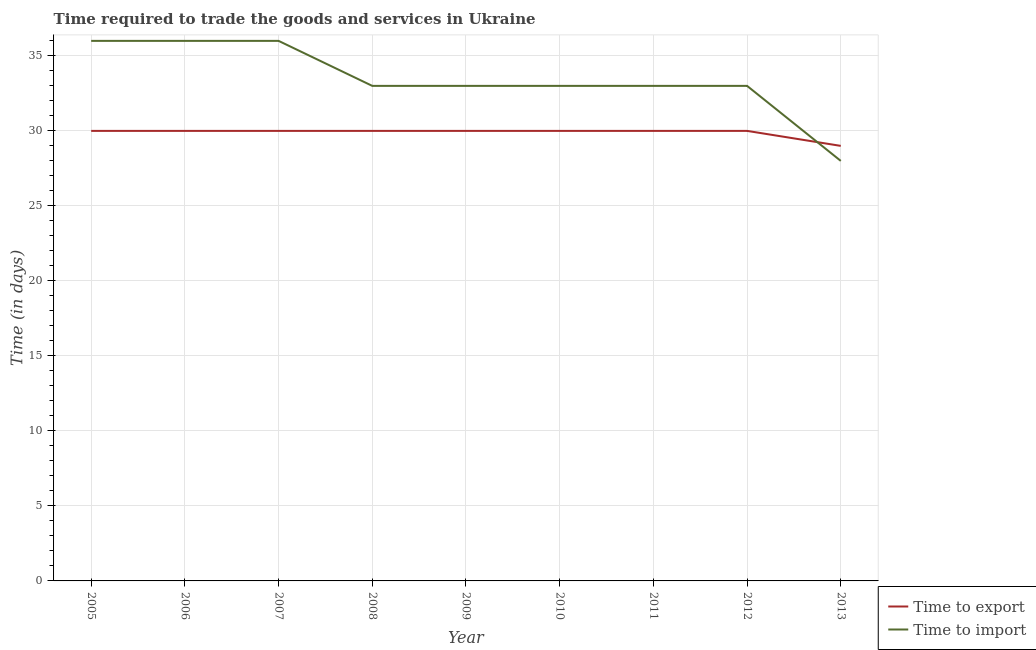Is the number of lines equal to the number of legend labels?
Your answer should be compact. Yes. What is the time to import in 2005?
Offer a very short reply. 36. Across all years, what is the maximum time to import?
Ensure brevity in your answer.  36. Across all years, what is the minimum time to import?
Provide a succinct answer. 28. In which year was the time to export minimum?
Ensure brevity in your answer.  2013. What is the total time to export in the graph?
Provide a succinct answer. 269. What is the difference between the time to import in 2005 and that in 2012?
Offer a terse response. 3. What is the difference between the time to export in 2010 and the time to import in 2009?
Your response must be concise. -3. What is the average time to import per year?
Your answer should be compact. 33.44. In the year 2008, what is the difference between the time to import and time to export?
Ensure brevity in your answer.  3. In how many years, is the time to export greater than 19 days?
Offer a terse response. 9. What is the ratio of the time to import in 2005 to that in 2013?
Your response must be concise. 1.29. Is the time to export in 2006 less than that in 2013?
Offer a terse response. No. What is the difference between the highest and the lowest time to export?
Your answer should be compact. 1. In how many years, is the time to import greater than the average time to import taken over all years?
Keep it short and to the point. 3. Is the sum of the time to import in 2010 and 2013 greater than the maximum time to export across all years?
Keep it short and to the point. Yes. Does the time to export monotonically increase over the years?
Offer a terse response. No. Is the time to import strictly greater than the time to export over the years?
Provide a short and direct response. No. Is the time to export strictly less than the time to import over the years?
Offer a terse response. No. How many lines are there?
Your response must be concise. 2. Does the graph contain any zero values?
Make the answer very short. No. Does the graph contain grids?
Offer a terse response. Yes. Where does the legend appear in the graph?
Your response must be concise. Bottom right. How many legend labels are there?
Provide a succinct answer. 2. How are the legend labels stacked?
Provide a succinct answer. Vertical. What is the title of the graph?
Your answer should be very brief. Time required to trade the goods and services in Ukraine. Does "Private creditors" appear as one of the legend labels in the graph?
Offer a very short reply. No. What is the label or title of the Y-axis?
Provide a succinct answer. Time (in days). What is the Time (in days) in Time to import in 2005?
Provide a succinct answer. 36. What is the Time (in days) in Time to export in 2006?
Your answer should be compact. 30. What is the Time (in days) of Time to import in 2006?
Your answer should be compact. 36. What is the Time (in days) in Time to export in 2008?
Ensure brevity in your answer.  30. What is the Time (in days) in Time to import in 2008?
Your answer should be very brief. 33. What is the Time (in days) in Time to export in 2009?
Your response must be concise. 30. What is the Time (in days) in Time to import in 2009?
Keep it short and to the point. 33. What is the Time (in days) in Time to export in 2011?
Ensure brevity in your answer.  30. What is the Time (in days) in Time to import in 2011?
Your response must be concise. 33. What is the Time (in days) in Time to export in 2012?
Your answer should be compact. 30. What is the Time (in days) in Time to import in 2012?
Your answer should be very brief. 33. What is the Time (in days) of Time to export in 2013?
Provide a short and direct response. 29. Across all years, what is the maximum Time (in days) in Time to export?
Your answer should be very brief. 30. Across all years, what is the minimum Time (in days) of Time to export?
Keep it short and to the point. 29. What is the total Time (in days) in Time to export in the graph?
Your response must be concise. 269. What is the total Time (in days) in Time to import in the graph?
Keep it short and to the point. 301. What is the difference between the Time (in days) in Time to import in 2005 and that in 2006?
Make the answer very short. 0. What is the difference between the Time (in days) in Time to import in 2005 and that in 2007?
Your response must be concise. 0. What is the difference between the Time (in days) in Time to export in 2005 and that in 2008?
Give a very brief answer. 0. What is the difference between the Time (in days) in Time to export in 2005 and that in 2009?
Give a very brief answer. 0. What is the difference between the Time (in days) in Time to import in 2005 and that in 2009?
Your answer should be compact. 3. What is the difference between the Time (in days) in Time to import in 2005 and that in 2010?
Offer a very short reply. 3. What is the difference between the Time (in days) of Time to import in 2005 and that in 2011?
Provide a succinct answer. 3. What is the difference between the Time (in days) of Time to export in 2005 and that in 2012?
Provide a succinct answer. 0. What is the difference between the Time (in days) in Time to import in 2005 and that in 2013?
Give a very brief answer. 8. What is the difference between the Time (in days) of Time to import in 2006 and that in 2007?
Make the answer very short. 0. What is the difference between the Time (in days) in Time to export in 2006 and that in 2008?
Offer a terse response. 0. What is the difference between the Time (in days) of Time to import in 2006 and that in 2008?
Provide a short and direct response. 3. What is the difference between the Time (in days) in Time to import in 2006 and that in 2010?
Provide a succinct answer. 3. What is the difference between the Time (in days) in Time to export in 2006 and that in 2011?
Offer a terse response. 0. What is the difference between the Time (in days) of Time to export in 2006 and that in 2012?
Your answer should be very brief. 0. What is the difference between the Time (in days) in Time to export in 2006 and that in 2013?
Provide a succinct answer. 1. What is the difference between the Time (in days) in Time to import in 2007 and that in 2008?
Ensure brevity in your answer.  3. What is the difference between the Time (in days) in Time to import in 2007 and that in 2009?
Give a very brief answer. 3. What is the difference between the Time (in days) of Time to import in 2007 and that in 2010?
Ensure brevity in your answer.  3. What is the difference between the Time (in days) in Time to export in 2007 and that in 2011?
Give a very brief answer. 0. What is the difference between the Time (in days) in Time to import in 2007 and that in 2011?
Your response must be concise. 3. What is the difference between the Time (in days) of Time to import in 2007 and that in 2012?
Keep it short and to the point. 3. What is the difference between the Time (in days) in Time to import in 2007 and that in 2013?
Make the answer very short. 8. What is the difference between the Time (in days) of Time to import in 2008 and that in 2009?
Provide a short and direct response. 0. What is the difference between the Time (in days) in Time to export in 2008 and that in 2010?
Provide a short and direct response. 0. What is the difference between the Time (in days) in Time to import in 2008 and that in 2012?
Offer a very short reply. 0. What is the difference between the Time (in days) of Time to export in 2009 and that in 2010?
Ensure brevity in your answer.  0. What is the difference between the Time (in days) in Time to import in 2009 and that in 2010?
Offer a terse response. 0. What is the difference between the Time (in days) of Time to export in 2009 and that in 2011?
Make the answer very short. 0. What is the difference between the Time (in days) in Time to import in 2009 and that in 2011?
Ensure brevity in your answer.  0. What is the difference between the Time (in days) of Time to import in 2009 and that in 2012?
Your answer should be compact. 0. What is the difference between the Time (in days) of Time to export in 2009 and that in 2013?
Ensure brevity in your answer.  1. What is the difference between the Time (in days) of Time to export in 2010 and that in 2011?
Ensure brevity in your answer.  0. What is the difference between the Time (in days) of Time to import in 2010 and that in 2011?
Ensure brevity in your answer.  0. What is the difference between the Time (in days) of Time to import in 2010 and that in 2012?
Your response must be concise. 0. What is the difference between the Time (in days) of Time to export in 2011 and that in 2012?
Make the answer very short. 0. What is the difference between the Time (in days) in Time to import in 2011 and that in 2012?
Provide a short and direct response. 0. What is the difference between the Time (in days) in Time to export in 2011 and that in 2013?
Your answer should be compact. 1. What is the difference between the Time (in days) of Time to export in 2012 and that in 2013?
Keep it short and to the point. 1. What is the difference between the Time (in days) in Time to export in 2005 and the Time (in days) in Time to import in 2006?
Offer a very short reply. -6. What is the difference between the Time (in days) in Time to export in 2005 and the Time (in days) in Time to import in 2008?
Your answer should be very brief. -3. What is the difference between the Time (in days) in Time to export in 2005 and the Time (in days) in Time to import in 2009?
Make the answer very short. -3. What is the difference between the Time (in days) in Time to export in 2005 and the Time (in days) in Time to import in 2011?
Offer a very short reply. -3. What is the difference between the Time (in days) of Time to export in 2005 and the Time (in days) of Time to import in 2012?
Give a very brief answer. -3. What is the difference between the Time (in days) of Time to export in 2005 and the Time (in days) of Time to import in 2013?
Your response must be concise. 2. What is the difference between the Time (in days) of Time to export in 2006 and the Time (in days) of Time to import in 2007?
Provide a succinct answer. -6. What is the difference between the Time (in days) of Time to export in 2006 and the Time (in days) of Time to import in 2008?
Your response must be concise. -3. What is the difference between the Time (in days) in Time to export in 2006 and the Time (in days) in Time to import in 2009?
Give a very brief answer. -3. What is the difference between the Time (in days) of Time to export in 2006 and the Time (in days) of Time to import in 2011?
Provide a succinct answer. -3. What is the difference between the Time (in days) in Time to export in 2007 and the Time (in days) in Time to import in 2012?
Make the answer very short. -3. What is the difference between the Time (in days) in Time to export in 2008 and the Time (in days) in Time to import in 2011?
Give a very brief answer. -3. What is the difference between the Time (in days) of Time to export in 2009 and the Time (in days) of Time to import in 2010?
Give a very brief answer. -3. What is the difference between the Time (in days) of Time to export in 2009 and the Time (in days) of Time to import in 2011?
Offer a very short reply. -3. What is the difference between the Time (in days) in Time to export in 2009 and the Time (in days) in Time to import in 2012?
Provide a succinct answer. -3. What is the difference between the Time (in days) in Time to export in 2009 and the Time (in days) in Time to import in 2013?
Your response must be concise. 2. What is the difference between the Time (in days) in Time to export in 2010 and the Time (in days) in Time to import in 2011?
Your response must be concise. -3. What is the difference between the Time (in days) of Time to export in 2010 and the Time (in days) of Time to import in 2012?
Your answer should be very brief. -3. What is the difference between the Time (in days) of Time to export in 2011 and the Time (in days) of Time to import in 2013?
Provide a short and direct response. 2. What is the average Time (in days) of Time to export per year?
Ensure brevity in your answer.  29.89. What is the average Time (in days) in Time to import per year?
Give a very brief answer. 33.44. In the year 2007, what is the difference between the Time (in days) in Time to export and Time (in days) in Time to import?
Provide a succinct answer. -6. In the year 2008, what is the difference between the Time (in days) in Time to export and Time (in days) in Time to import?
Your answer should be compact. -3. In the year 2010, what is the difference between the Time (in days) in Time to export and Time (in days) in Time to import?
Offer a very short reply. -3. In the year 2011, what is the difference between the Time (in days) of Time to export and Time (in days) of Time to import?
Give a very brief answer. -3. What is the ratio of the Time (in days) of Time to export in 2005 to that in 2006?
Your answer should be compact. 1. What is the ratio of the Time (in days) in Time to import in 2005 to that in 2006?
Provide a succinct answer. 1. What is the ratio of the Time (in days) in Time to export in 2005 to that in 2008?
Offer a terse response. 1. What is the ratio of the Time (in days) in Time to import in 2005 to that in 2008?
Ensure brevity in your answer.  1.09. What is the ratio of the Time (in days) of Time to export in 2005 to that in 2009?
Provide a succinct answer. 1. What is the ratio of the Time (in days) in Time to import in 2005 to that in 2009?
Ensure brevity in your answer.  1.09. What is the ratio of the Time (in days) of Time to export in 2005 to that in 2013?
Offer a very short reply. 1.03. What is the ratio of the Time (in days) of Time to export in 2006 to that in 2007?
Offer a very short reply. 1. What is the ratio of the Time (in days) of Time to export in 2006 to that in 2008?
Your answer should be compact. 1. What is the ratio of the Time (in days) in Time to import in 2006 to that in 2008?
Give a very brief answer. 1.09. What is the ratio of the Time (in days) in Time to import in 2006 to that in 2009?
Provide a short and direct response. 1.09. What is the ratio of the Time (in days) of Time to import in 2006 to that in 2010?
Offer a terse response. 1.09. What is the ratio of the Time (in days) of Time to export in 2006 to that in 2011?
Provide a succinct answer. 1. What is the ratio of the Time (in days) in Time to import in 2006 to that in 2011?
Give a very brief answer. 1.09. What is the ratio of the Time (in days) in Time to export in 2006 to that in 2012?
Ensure brevity in your answer.  1. What is the ratio of the Time (in days) of Time to import in 2006 to that in 2012?
Give a very brief answer. 1.09. What is the ratio of the Time (in days) in Time to export in 2006 to that in 2013?
Make the answer very short. 1.03. What is the ratio of the Time (in days) in Time to export in 2007 to that in 2008?
Your answer should be compact. 1. What is the ratio of the Time (in days) in Time to import in 2007 to that in 2008?
Offer a terse response. 1.09. What is the ratio of the Time (in days) in Time to import in 2007 to that in 2009?
Make the answer very short. 1.09. What is the ratio of the Time (in days) in Time to export in 2007 to that in 2010?
Make the answer very short. 1. What is the ratio of the Time (in days) of Time to export in 2007 to that in 2012?
Make the answer very short. 1. What is the ratio of the Time (in days) of Time to export in 2007 to that in 2013?
Provide a short and direct response. 1.03. What is the ratio of the Time (in days) of Time to import in 2007 to that in 2013?
Provide a succinct answer. 1.29. What is the ratio of the Time (in days) of Time to import in 2008 to that in 2010?
Your response must be concise. 1. What is the ratio of the Time (in days) in Time to import in 2008 to that in 2011?
Your response must be concise. 1. What is the ratio of the Time (in days) of Time to export in 2008 to that in 2012?
Keep it short and to the point. 1. What is the ratio of the Time (in days) in Time to import in 2008 to that in 2012?
Give a very brief answer. 1. What is the ratio of the Time (in days) in Time to export in 2008 to that in 2013?
Give a very brief answer. 1.03. What is the ratio of the Time (in days) in Time to import in 2008 to that in 2013?
Provide a succinct answer. 1.18. What is the ratio of the Time (in days) of Time to import in 2009 to that in 2010?
Your response must be concise. 1. What is the ratio of the Time (in days) in Time to export in 2009 to that in 2011?
Ensure brevity in your answer.  1. What is the ratio of the Time (in days) of Time to import in 2009 to that in 2011?
Provide a succinct answer. 1. What is the ratio of the Time (in days) of Time to export in 2009 to that in 2012?
Offer a very short reply. 1. What is the ratio of the Time (in days) of Time to export in 2009 to that in 2013?
Keep it short and to the point. 1.03. What is the ratio of the Time (in days) of Time to import in 2009 to that in 2013?
Provide a short and direct response. 1.18. What is the ratio of the Time (in days) in Time to export in 2010 to that in 2011?
Your response must be concise. 1. What is the ratio of the Time (in days) in Time to export in 2010 to that in 2013?
Make the answer very short. 1.03. What is the ratio of the Time (in days) of Time to import in 2010 to that in 2013?
Give a very brief answer. 1.18. What is the ratio of the Time (in days) in Time to export in 2011 to that in 2012?
Your answer should be compact. 1. What is the ratio of the Time (in days) of Time to export in 2011 to that in 2013?
Provide a succinct answer. 1.03. What is the ratio of the Time (in days) of Time to import in 2011 to that in 2013?
Provide a short and direct response. 1.18. What is the ratio of the Time (in days) of Time to export in 2012 to that in 2013?
Provide a short and direct response. 1.03. What is the ratio of the Time (in days) of Time to import in 2012 to that in 2013?
Give a very brief answer. 1.18. What is the difference between the highest and the second highest Time (in days) in Time to export?
Keep it short and to the point. 0. What is the difference between the highest and the second highest Time (in days) of Time to import?
Your answer should be compact. 0. What is the difference between the highest and the lowest Time (in days) of Time to export?
Provide a short and direct response. 1. 